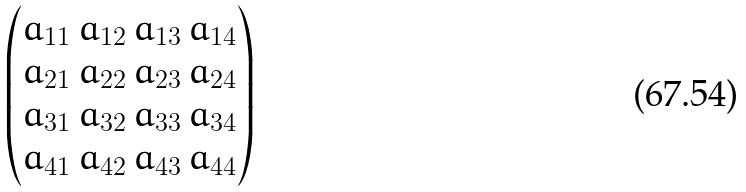<formula> <loc_0><loc_0><loc_500><loc_500>\begin{pmatrix} a _ { 1 1 } \, a _ { 1 2 } \, a _ { 1 3 } \, a _ { 1 4 } \\ a _ { 2 1 } \, a _ { 2 2 } \, a _ { 2 3 } \, a _ { 2 4 } \\ a _ { 3 1 } \, a _ { 3 2 } \, a _ { 3 3 } \, a _ { 3 4 } \\ a _ { 4 1 } \, a _ { 4 2 } \, a _ { 4 3 } \, a _ { 4 4 } \end{pmatrix}</formula> 